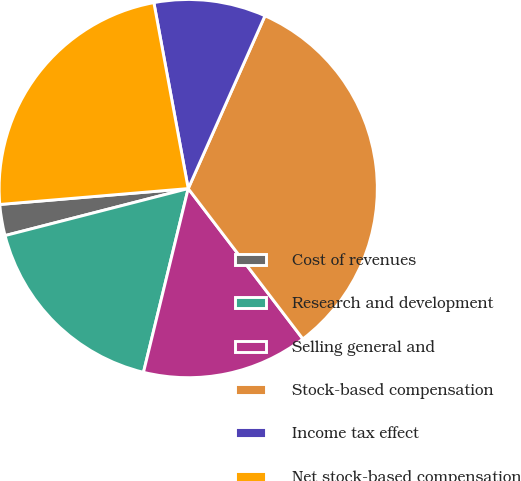Convert chart to OTSL. <chart><loc_0><loc_0><loc_500><loc_500><pie_chart><fcel>Cost of revenues<fcel>Research and development<fcel>Selling general and<fcel>Stock-based compensation<fcel>Income tax effect<fcel>Net stock-based compensation<nl><fcel>2.66%<fcel>17.2%<fcel>14.17%<fcel>32.98%<fcel>9.56%<fcel>23.43%<nl></chart> 